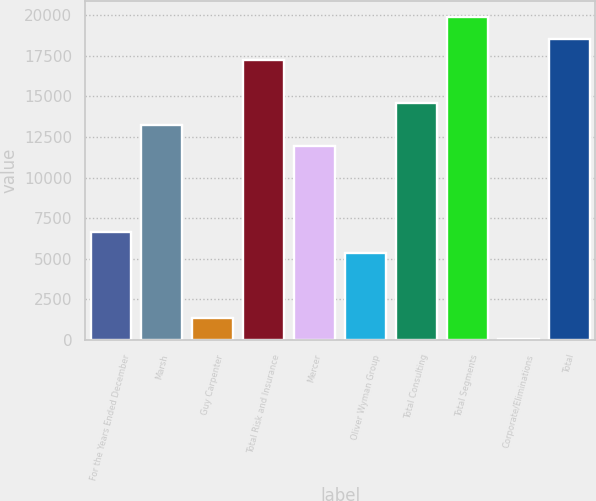Convert chart. <chart><loc_0><loc_0><loc_500><loc_500><bar_chart><fcel>For the Years Ended December<fcel>Marsh<fcel>Guy Carpenter<fcel>Total Risk and Insurance<fcel>Mercer<fcel>Oliver Wyman Group<fcel>Total Consulting<fcel>Total Segments<fcel>Corporate/Eliminations<fcel>Total<nl><fcel>6649.5<fcel>13255<fcel>1365.1<fcel>17218.3<fcel>11933.9<fcel>5328.4<fcel>14576.1<fcel>19860.5<fcel>44<fcel>18539.4<nl></chart> 